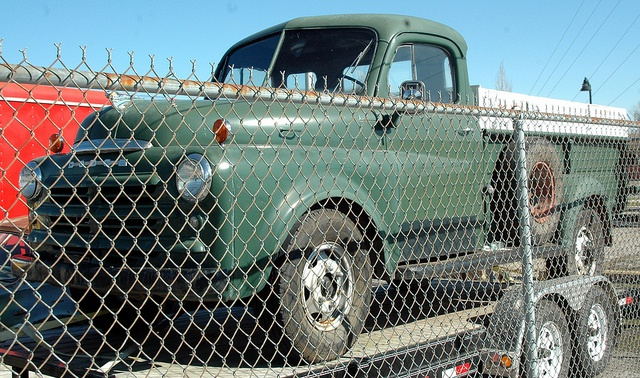Describe the objects in this image and their specific colors. I can see a truck in lightblue, black, gray, darkgray, and teal tones in this image. 